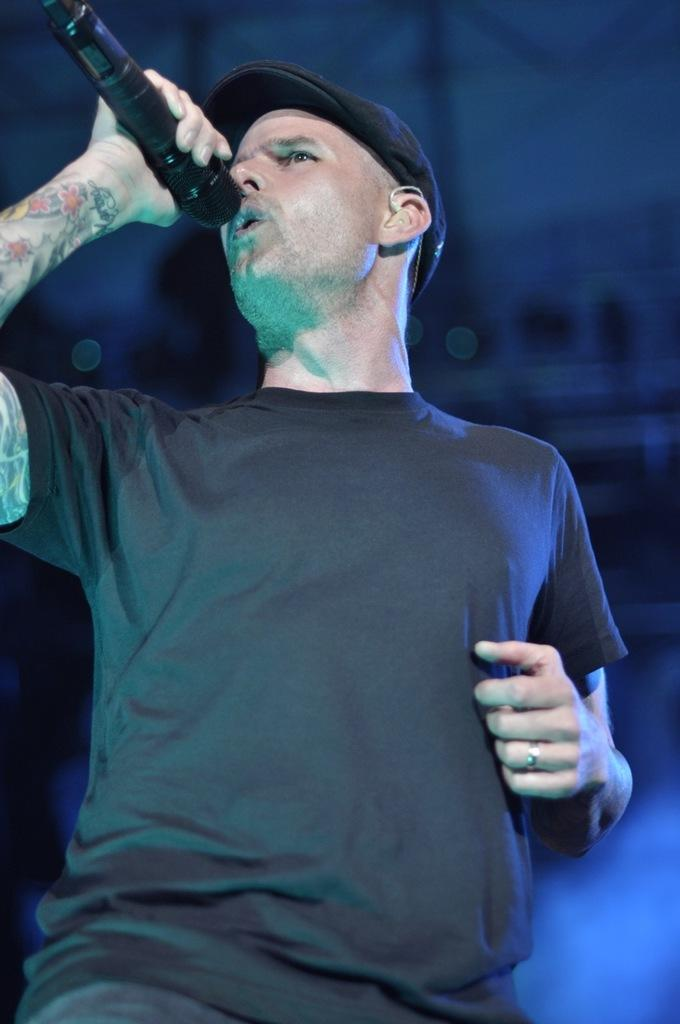What is the man in the image doing? The man is signing in the image. What is the man wearing on his head? The man is wearing a black cap on his head. What is the man holding in the image? The man is holding a microphone. What can be seen on the man's hand? There is a tattoo on the man's hand. What is the man's sister doing in the image? There is no mention of a sister in the image, so we cannot answer this question. 